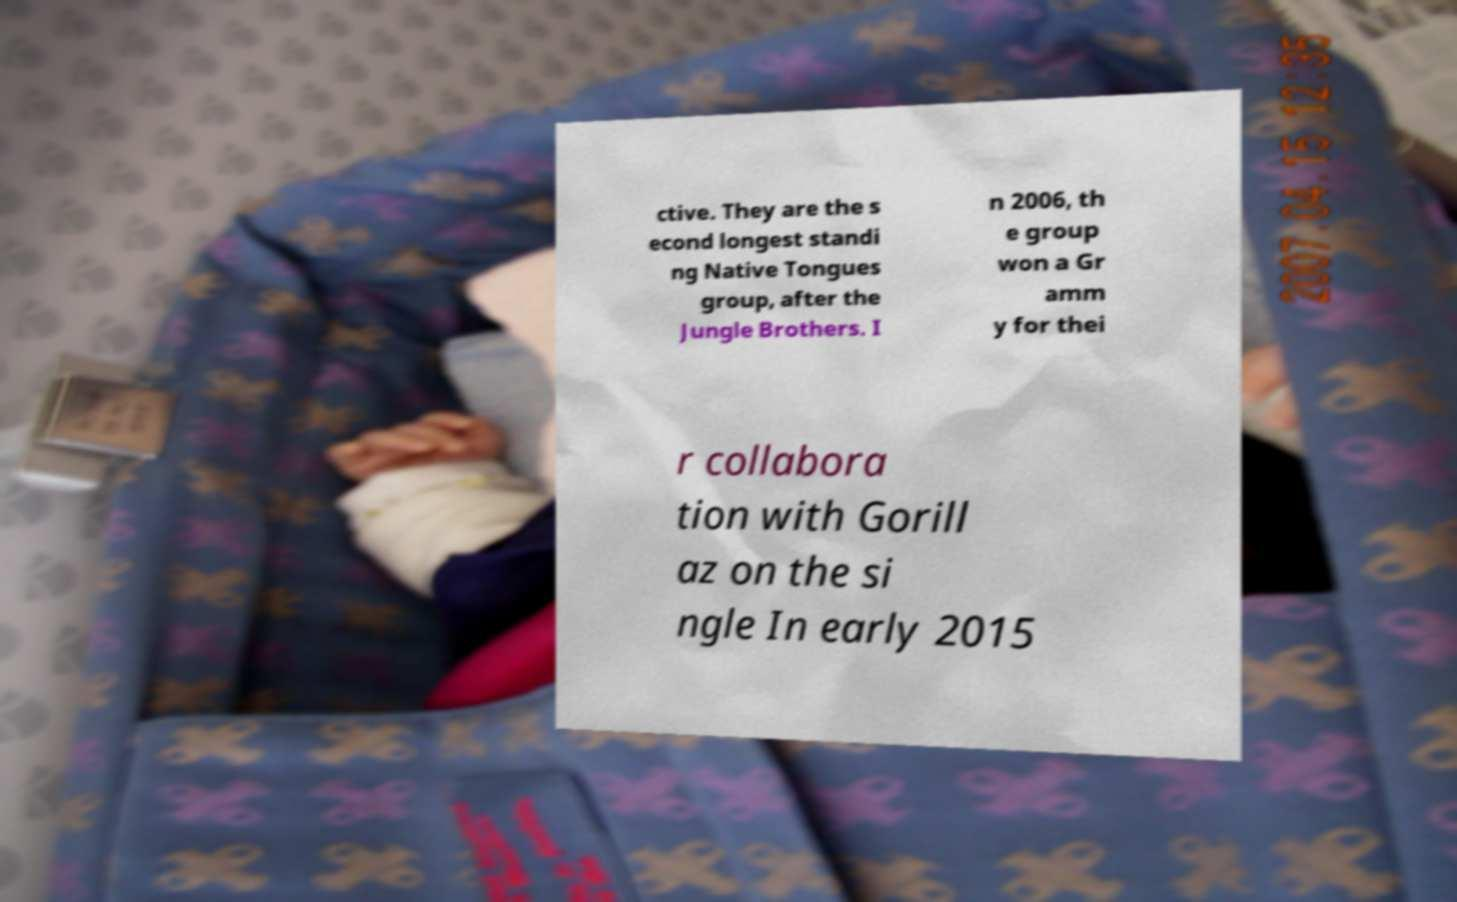Could you extract and type out the text from this image? ctive. They are the s econd longest standi ng Native Tongues group, after the Jungle Brothers. I n 2006, th e group won a Gr amm y for thei r collabora tion with Gorill az on the si ngle In early 2015 